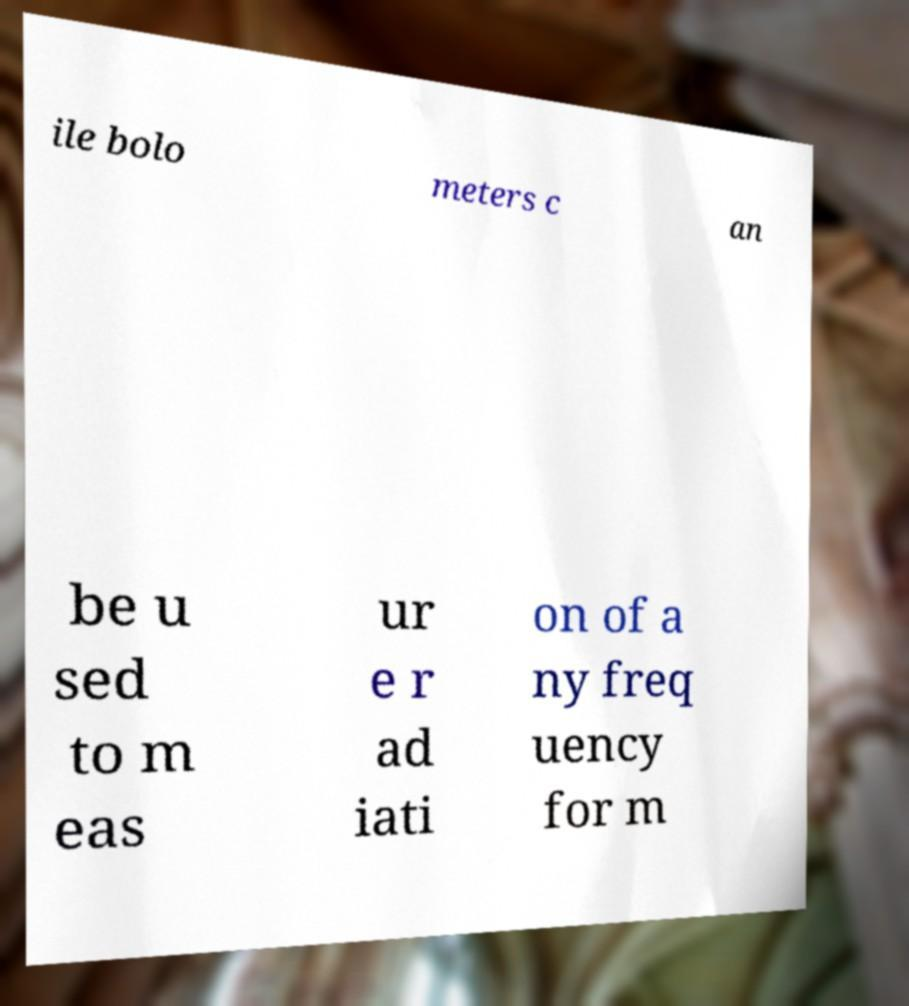What messages or text are displayed in this image? I need them in a readable, typed format. ile bolo meters c an be u sed to m eas ur e r ad iati on of a ny freq uency for m 